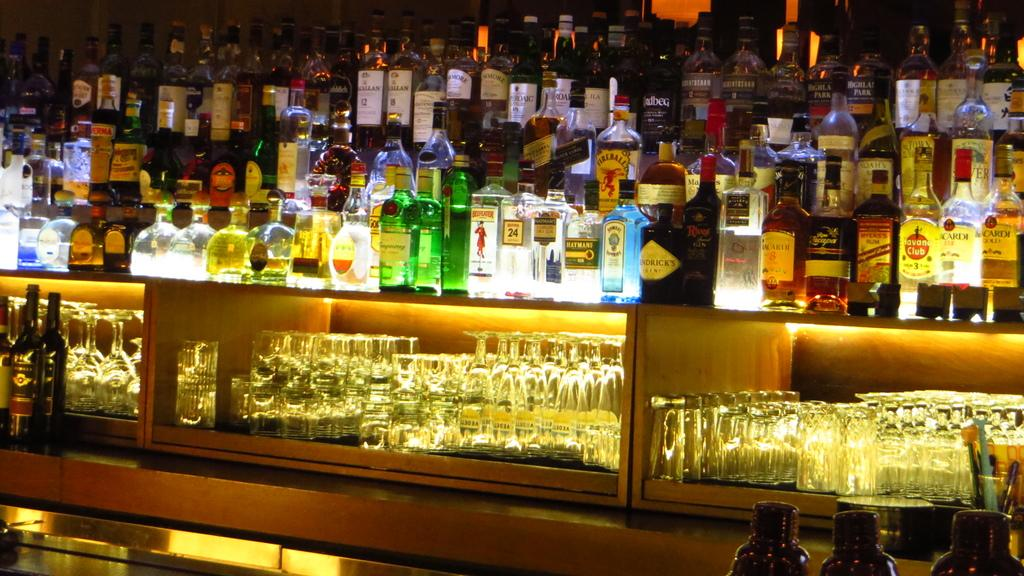What type of establishment is the image taken in? The image is taken inside a bar. What can be seen on the desk in the image? There are wine bottles and empty glasses on the desk. What type of shoes are the bartenders wearing in the image? There is no information about bartenders or their shoes in the image. 